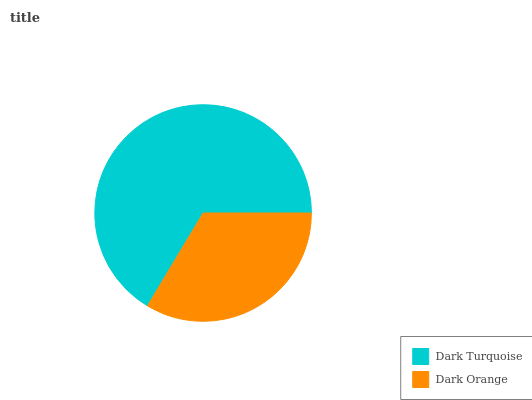Is Dark Orange the minimum?
Answer yes or no. Yes. Is Dark Turquoise the maximum?
Answer yes or no. Yes. Is Dark Orange the maximum?
Answer yes or no. No. Is Dark Turquoise greater than Dark Orange?
Answer yes or no. Yes. Is Dark Orange less than Dark Turquoise?
Answer yes or no. Yes. Is Dark Orange greater than Dark Turquoise?
Answer yes or no. No. Is Dark Turquoise less than Dark Orange?
Answer yes or no. No. Is Dark Turquoise the high median?
Answer yes or no. Yes. Is Dark Orange the low median?
Answer yes or no. Yes. Is Dark Orange the high median?
Answer yes or no. No. Is Dark Turquoise the low median?
Answer yes or no. No. 